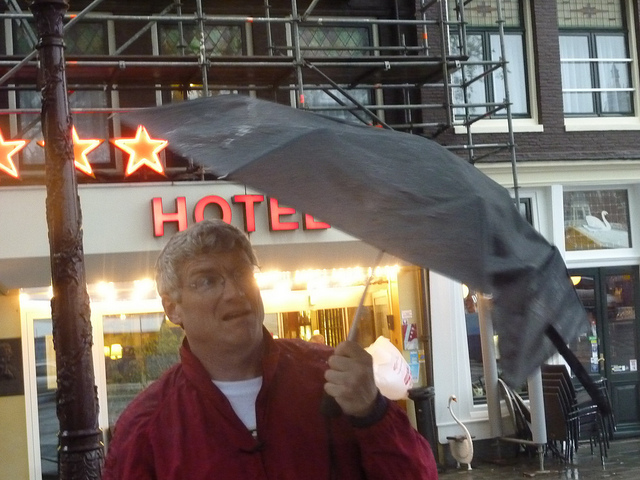How many train cars are painted black? The question seems to be based on a misunderstanding, as the image doesn't depict any train cars at all. Instead, we see a person struggling with a flipped umbrella on a windy day. There are no trains visible in this scene. 